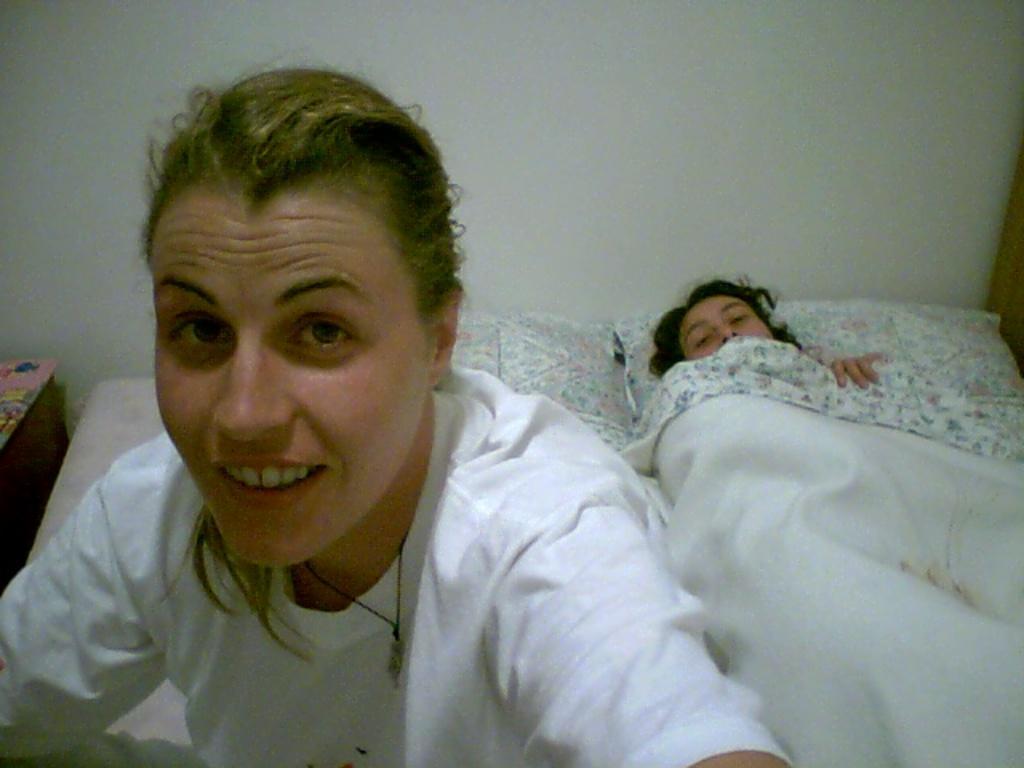Describe this image in one or two sentences. In the image we can see in front there is a woman sitting on the bed and there is other person is lying on the bed. There are pillows and blanket on the bed. Behind there is a wall which is in white colour. 